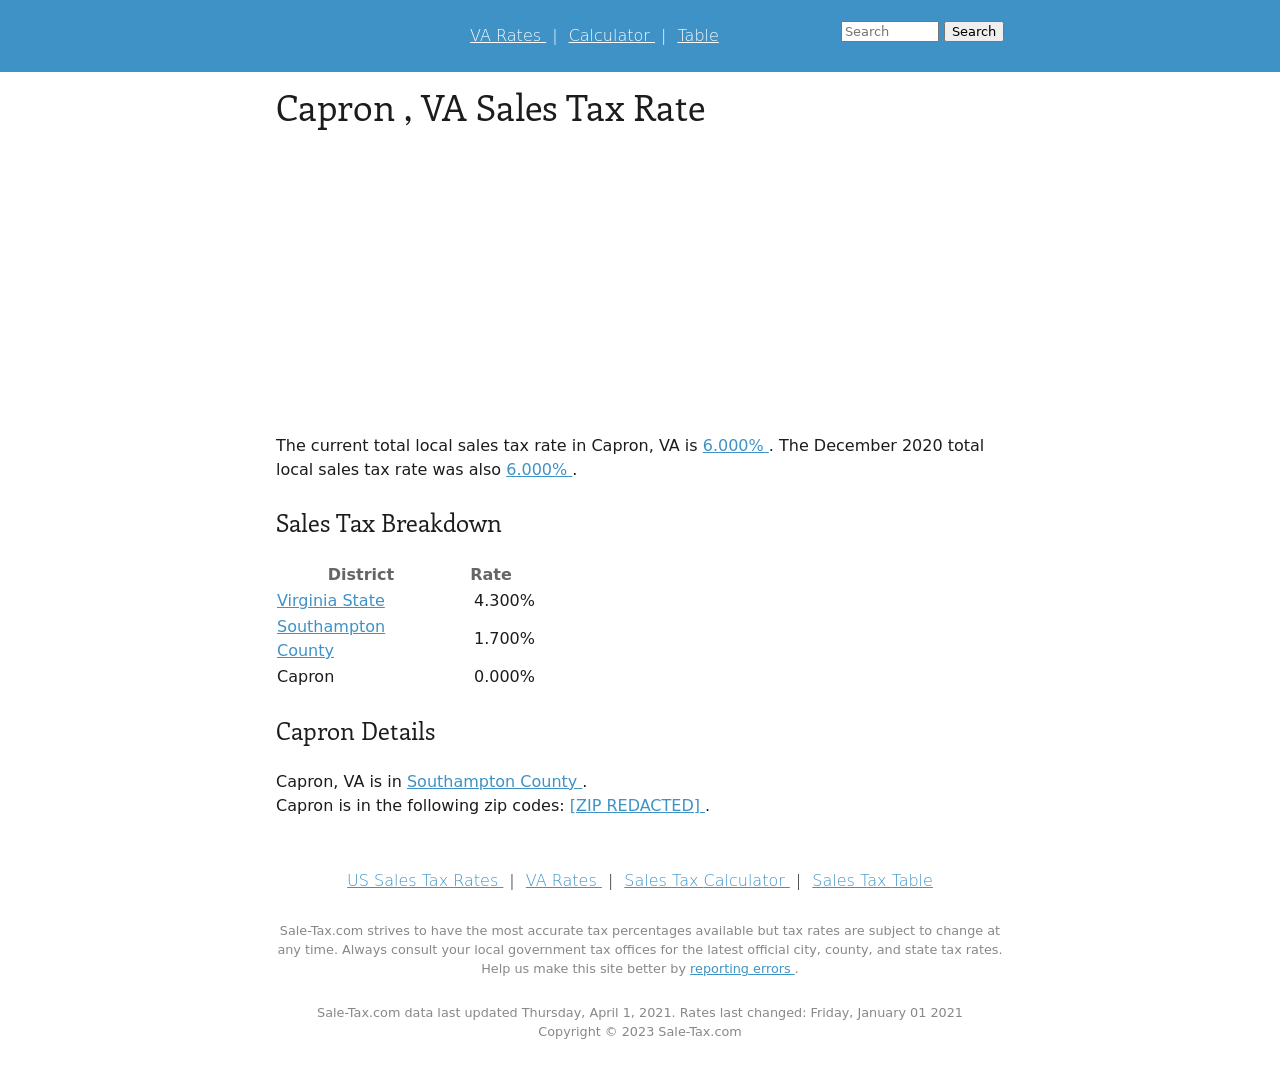What's the procedure for constructing this website from scratch with HTML? To construct a website similar to the one in the image from scratch using HTML, you'll need to start by defining the basic structure with HTML tags. Here are the steps:
1. **Setup the Document**: Start with the <!DOCTYPE html> declaration and the <html> element. Inside, you'll include <head> and <body> sections.
2. **Head Section**: Inside the <head>, place your <title>, <meta> tags for responsiveness and character set, and link your CSS for styles.
3. **Body Content**: Use <div> tags to create structured segments like headers, content sections, tables, and footers. Include elements like <h1>, <p>, and <a> for text and links.
4. **Styling**: Write CSS rules to format the layout, fonts, and colors as seen in the image, applying styles to your HTML elements to match the clean and professional look.
5. **Testing**: Preview your page in different browsers to ensure compatibility and make adjustments as needed.
6. **Launch**: Once complete and tested, upload the files to a web server to make your website accessible to others.
This is a basic outline; detailed HTML knowledge and styling with CSS will enhance the quality and functionality of the site. 